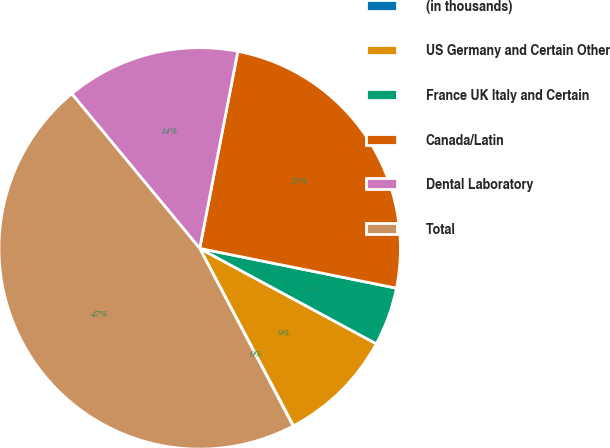<chart> <loc_0><loc_0><loc_500><loc_500><pie_chart><fcel>(in thousands)<fcel>US Germany and Certain Other<fcel>France UK Italy and Certain<fcel>Canada/Latin<fcel>Dental Laboratory<fcel>Total<nl><fcel>0.04%<fcel>9.37%<fcel>4.71%<fcel>25.13%<fcel>14.04%<fcel>46.7%<nl></chart> 